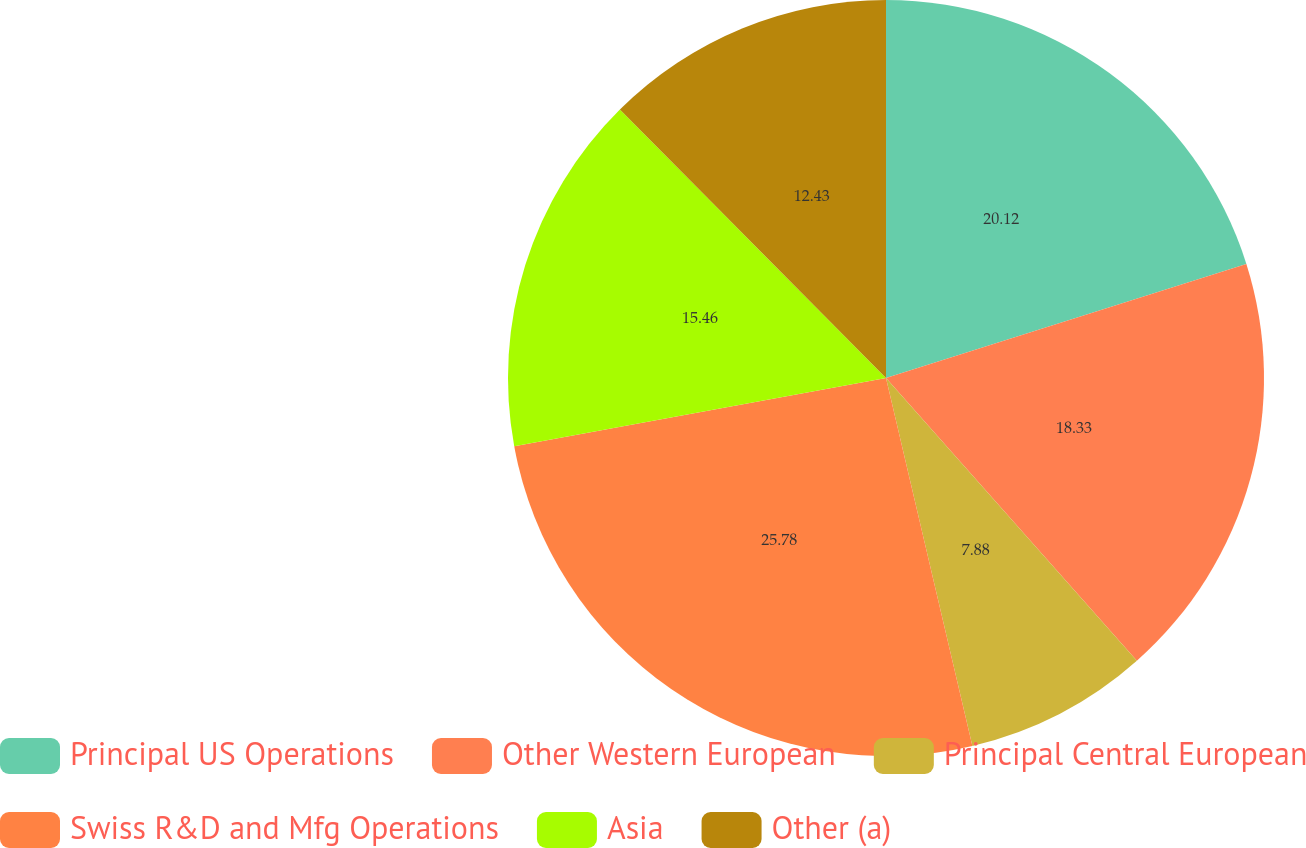<chart> <loc_0><loc_0><loc_500><loc_500><pie_chart><fcel>Principal US Operations<fcel>Other Western European<fcel>Principal Central European<fcel>Swiss R&D and Mfg Operations<fcel>Asia<fcel>Other (a)<nl><fcel>20.12%<fcel>18.33%<fcel>7.88%<fcel>25.78%<fcel>15.46%<fcel>12.43%<nl></chart> 